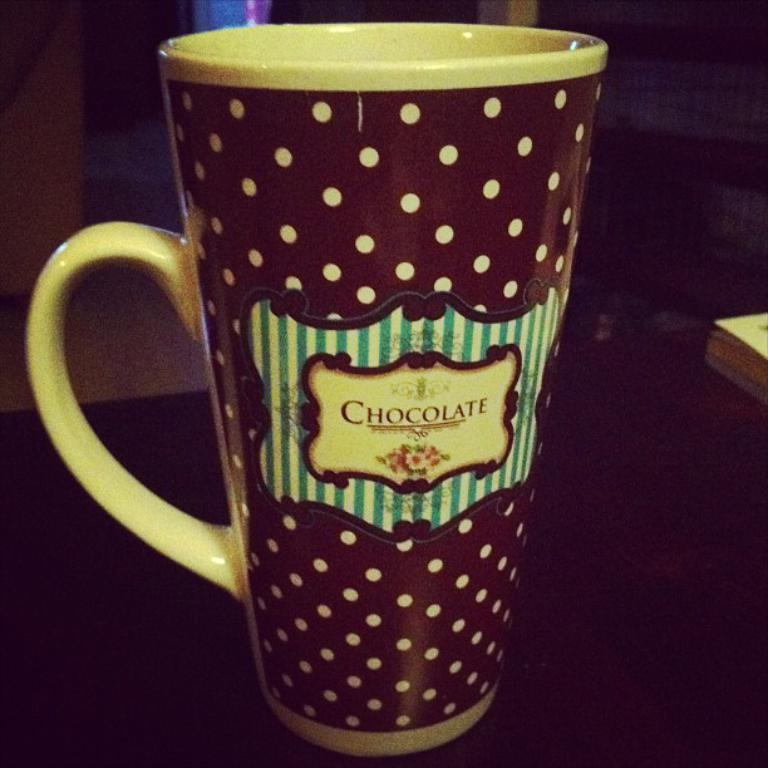<image>
Render a clear and concise summary of the photo. A coffee mug says chocolate on it and is covered in polka dots. 